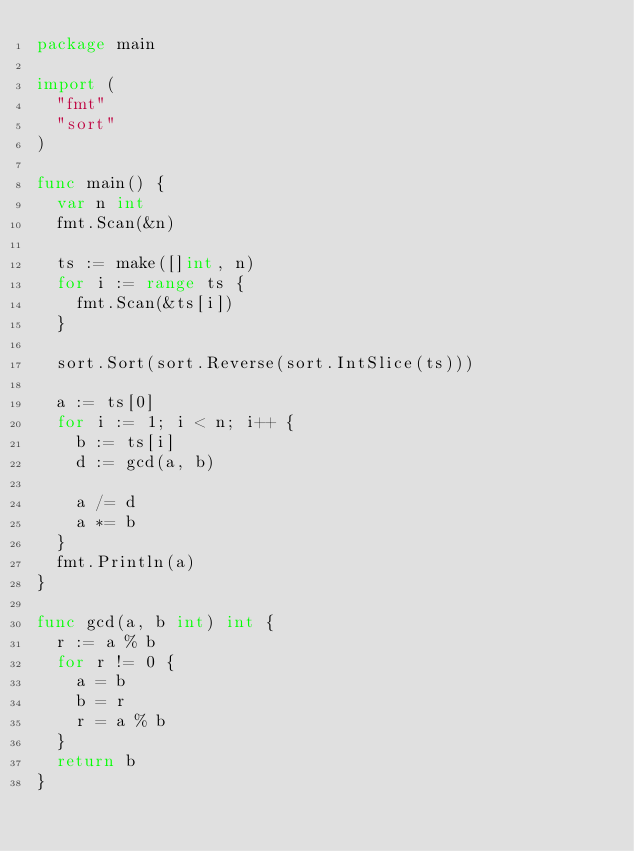Convert code to text. <code><loc_0><loc_0><loc_500><loc_500><_Go_>package main

import (
	"fmt"
	"sort"
)

func main() {
	var n int
	fmt.Scan(&n)

	ts := make([]int, n)
	for i := range ts {
		fmt.Scan(&ts[i])
	}

	sort.Sort(sort.Reverse(sort.IntSlice(ts)))

	a := ts[0]
	for i := 1; i < n; i++ {
		b := ts[i]
		d := gcd(a, b)

		a /= d
		a *= b
	}
	fmt.Println(a)
}

func gcd(a, b int) int {
	r := a % b
	for r != 0 {
		a = b
		b = r
		r = a % b
	}
	return b
}
</code> 